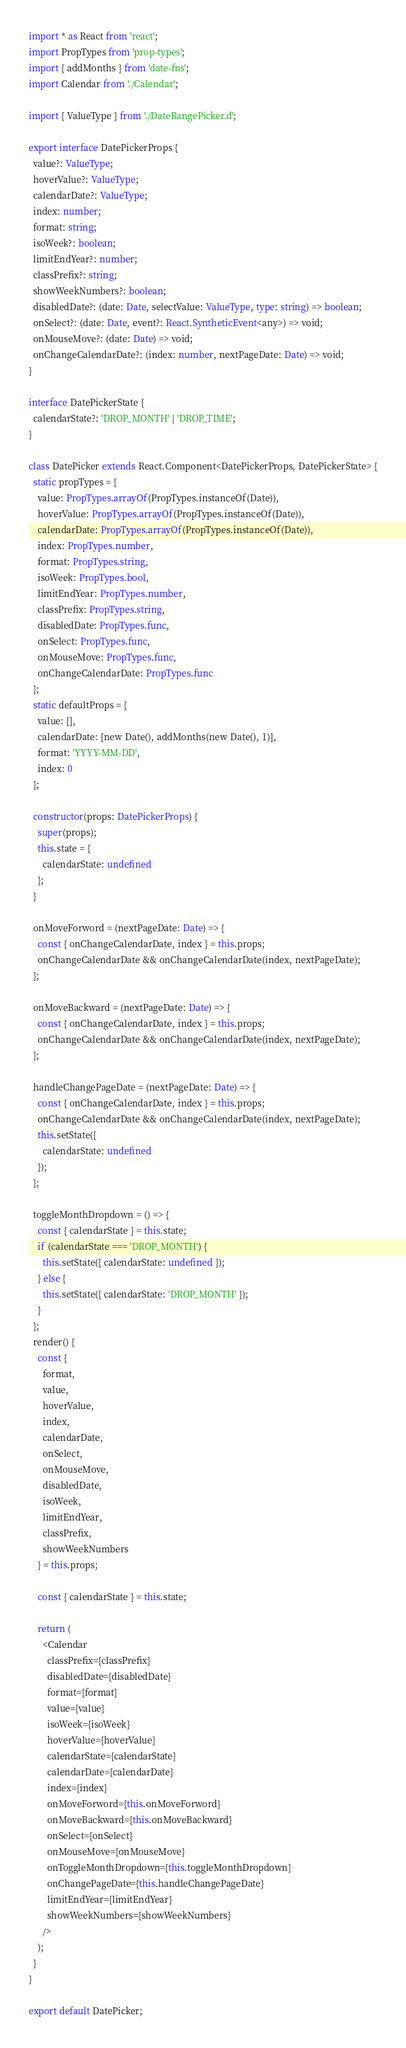Convert code to text. <code><loc_0><loc_0><loc_500><loc_500><_TypeScript_>import * as React from 'react';
import PropTypes from 'prop-types';
import { addMonths } from 'date-fns';
import Calendar from './Calendar';

import { ValueType } from './DateRangePicker.d';

export interface DatePickerProps {
  value?: ValueType;
  hoverValue?: ValueType;
  calendarDate?: ValueType;
  index: number;
  format: string;
  isoWeek?: boolean;
  limitEndYear?: number;
  classPrefix?: string;
  showWeekNumbers?: boolean;
  disabledDate?: (date: Date, selectValue: ValueType, type: string) => boolean;
  onSelect?: (date: Date, event?: React.SyntheticEvent<any>) => void;
  onMouseMove?: (date: Date) => void;
  onChangeCalendarDate?: (index: number, nextPageDate: Date) => void;
}

interface DatePickerState {
  calendarState?: 'DROP_MONTH' | 'DROP_TIME';
}

class DatePicker extends React.Component<DatePickerProps, DatePickerState> {
  static propTypes = {
    value: PropTypes.arrayOf(PropTypes.instanceOf(Date)),
    hoverValue: PropTypes.arrayOf(PropTypes.instanceOf(Date)),
    calendarDate: PropTypes.arrayOf(PropTypes.instanceOf(Date)),
    index: PropTypes.number,
    format: PropTypes.string,
    isoWeek: PropTypes.bool,
    limitEndYear: PropTypes.number,
    classPrefix: PropTypes.string,
    disabledDate: PropTypes.func,
    onSelect: PropTypes.func,
    onMouseMove: PropTypes.func,
    onChangeCalendarDate: PropTypes.func
  };
  static defaultProps = {
    value: [],
    calendarDate: [new Date(), addMonths(new Date(), 1)],
    format: 'YYYY-MM-DD',
    index: 0
  };

  constructor(props: DatePickerProps) {
    super(props);
    this.state = {
      calendarState: undefined
    };
  }

  onMoveForword = (nextPageDate: Date) => {
    const { onChangeCalendarDate, index } = this.props;
    onChangeCalendarDate && onChangeCalendarDate(index, nextPageDate);
  };

  onMoveBackward = (nextPageDate: Date) => {
    const { onChangeCalendarDate, index } = this.props;
    onChangeCalendarDate && onChangeCalendarDate(index, nextPageDate);
  };

  handleChangePageDate = (nextPageDate: Date) => {
    const { onChangeCalendarDate, index } = this.props;
    onChangeCalendarDate && onChangeCalendarDate(index, nextPageDate);
    this.setState({
      calendarState: undefined
    });
  };

  toggleMonthDropdown = () => {
    const { calendarState } = this.state;
    if (calendarState === 'DROP_MONTH') {
      this.setState({ calendarState: undefined });
    } else {
      this.setState({ calendarState: 'DROP_MONTH' });
    }
  };
  render() {
    const {
      format,
      value,
      hoverValue,
      index,
      calendarDate,
      onSelect,
      onMouseMove,
      disabledDate,
      isoWeek,
      limitEndYear,
      classPrefix,
      showWeekNumbers
    } = this.props;

    const { calendarState } = this.state;

    return (
      <Calendar
        classPrefix={classPrefix}
        disabledDate={disabledDate}
        format={format}
        value={value}
        isoWeek={isoWeek}
        hoverValue={hoverValue}
        calendarState={calendarState}
        calendarDate={calendarDate}
        index={index}
        onMoveForword={this.onMoveForword}
        onMoveBackward={this.onMoveBackward}
        onSelect={onSelect}
        onMouseMove={onMouseMove}
        onToggleMonthDropdown={this.toggleMonthDropdown}
        onChangePageDate={this.handleChangePageDate}
        limitEndYear={limitEndYear}
        showWeekNumbers={showWeekNumbers}
      />
    );
  }
}

export default DatePicker;
</code> 